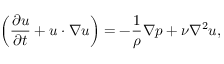Convert formula to latex. <formula><loc_0><loc_0><loc_500><loc_500>\left ( \frac { \partial u } { \partial t } + u \cdot \nabla u \right ) = - \frac { 1 } { \rho } \nabla p + \nu \nabla ^ { 2 } u ,</formula> 